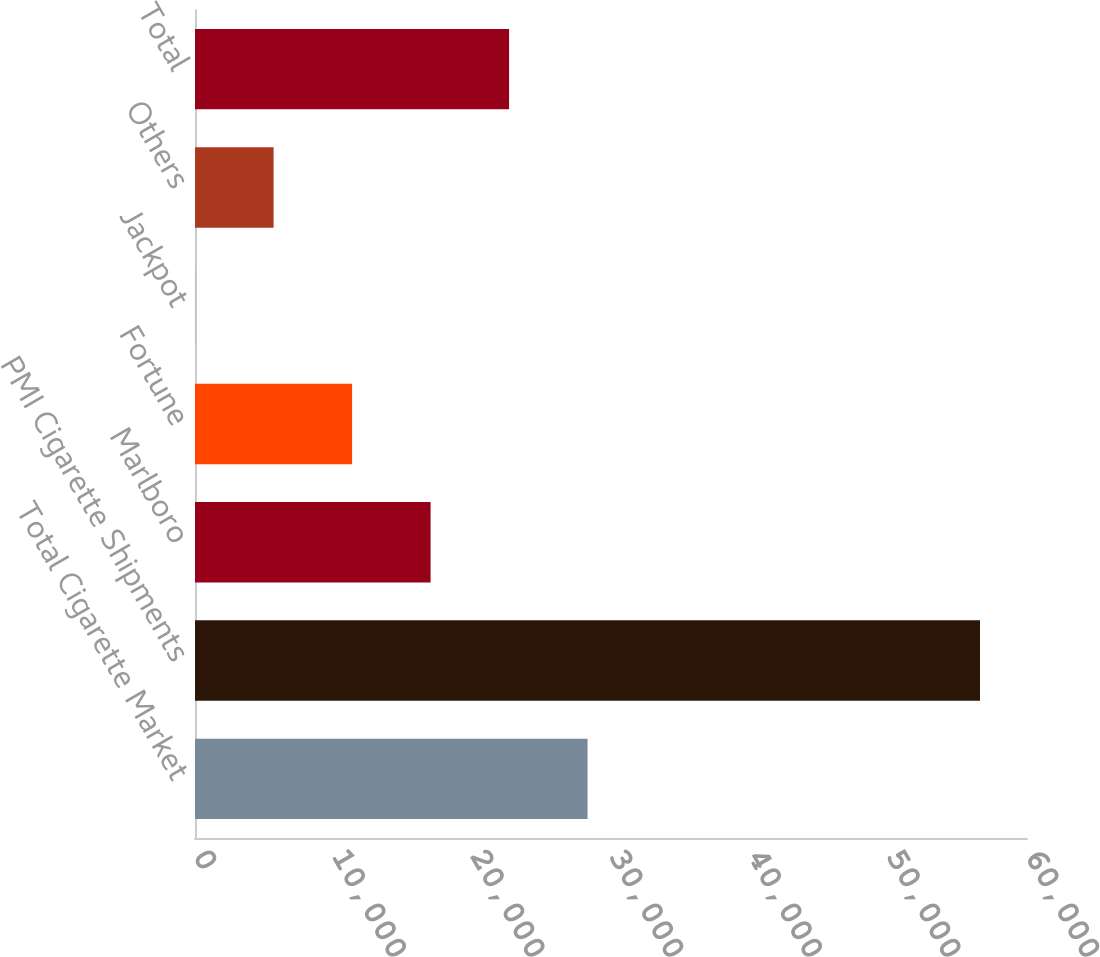<chart> <loc_0><loc_0><loc_500><loc_500><bar_chart><fcel>Total Cigarette Market<fcel>PMI Cigarette Shipments<fcel>Marlboro<fcel>Fortune<fcel>Jackpot<fcel>Others<fcel>Total<nl><fcel>28309.5<fcel>56611<fcel>16988.8<fcel>11328.5<fcel>7.9<fcel>5668.21<fcel>22649.1<nl></chart> 